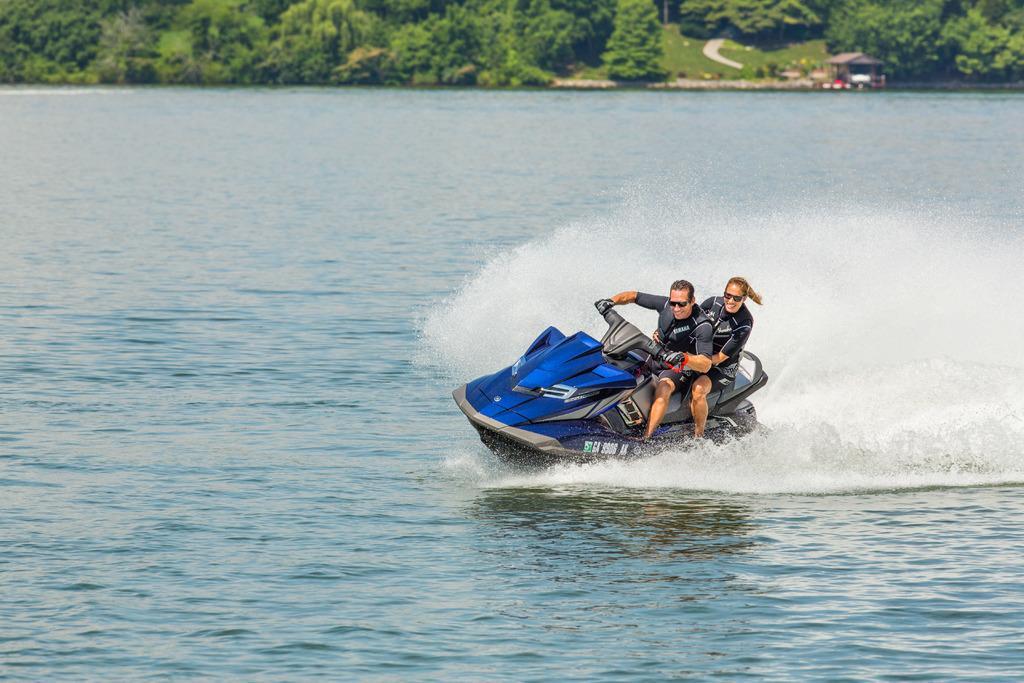Could you give a brief overview of what you see in this image? In this image we can see these two persons are sitting on the jet ski which is floating on the water. In the background, we can see trees and wooden house here. 